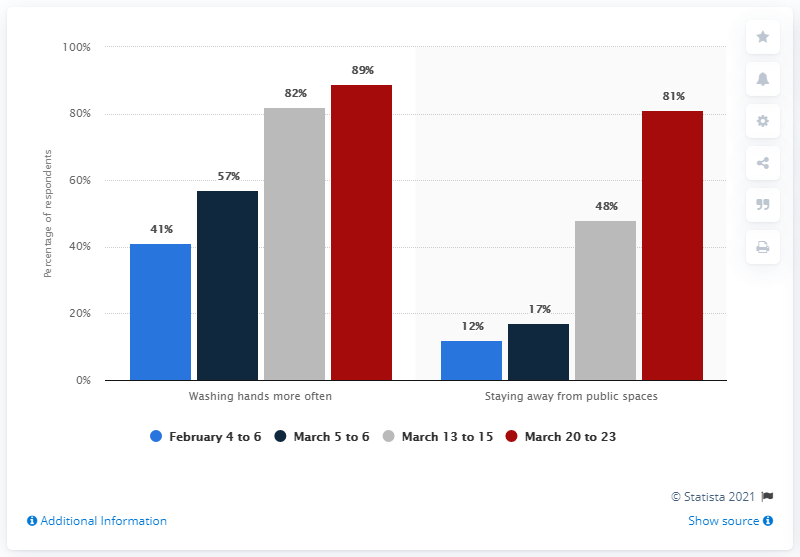Outline some significant characteristics in this image. According to a survey, the percentage of adults who reported staying away from public places due to COVID-19 increased from 12% to 81% between January and July 2020. 